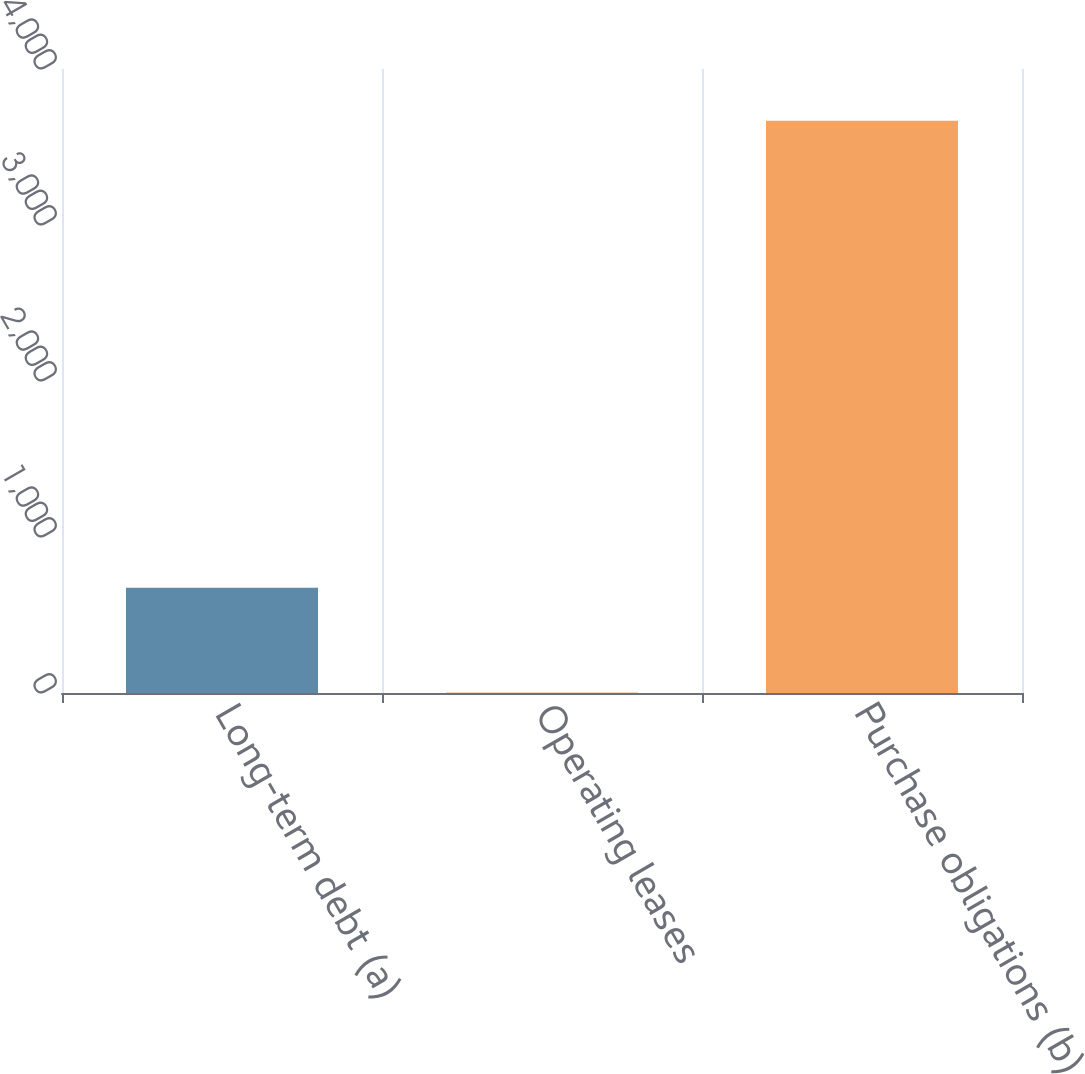Convert chart. <chart><loc_0><loc_0><loc_500><loc_500><bar_chart><fcel>Long-term debt (a)<fcel>Operating leases<fcel>Purchase obligations (b)<nl><fcel>674<fcel>2<fcel>3669<nl></chart> 